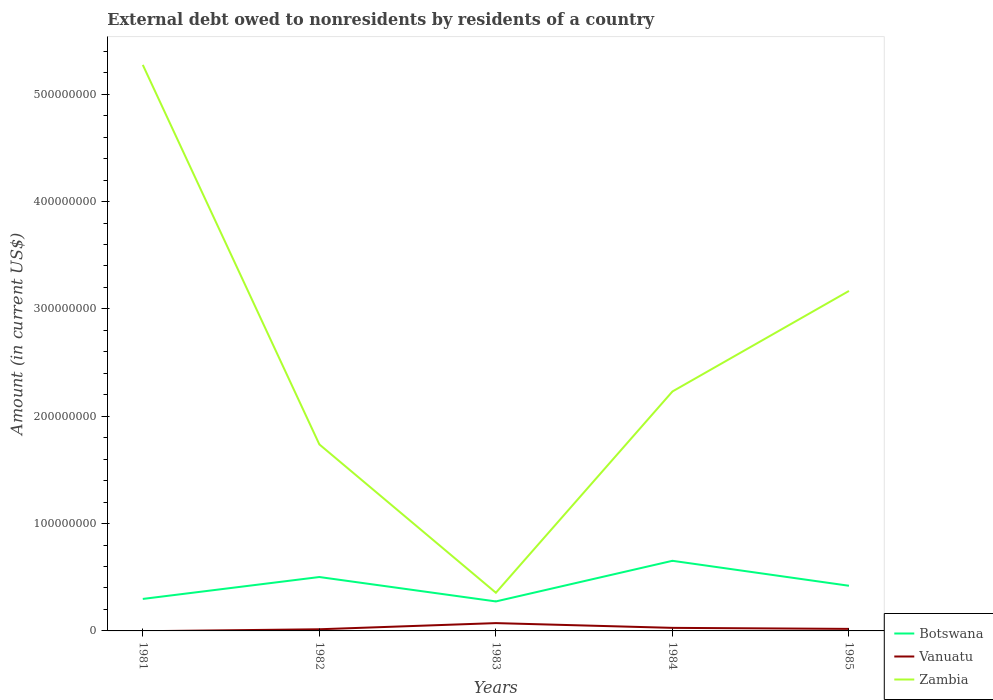Across all years, what is the maximum external debt owed by residents in Botswana?
Offer a very short reply. 2.75e+07. What is the total external debt owed by residents in Zambia in the graph?
Offer a very short reply. -2.81e+08. What is the difference between the highest and the second highest external debt owed by residents in Zambia?
Ensure brevity in your answer.  4.92e+08. What is the difference between the highest and the lowest external debt owed by residents in Zambia?
Ensure brevity in your answer.  2. How many lines are there?
Your answer should be very brief. 3. Are the values on the major ticks of Y-axis written in scientific E-notation?
Make the answer very short. No. Does the graph contain grids?
Provide a short and direct response. No. Where does the legend appear in the graph?
Offer a very short reply. Bottom right. How many legend labels are there?
Keep it short and to the point. 3. What is the title of the graph?
Provide a short and direct response. External debt owed to nonresidents by residents of a country. What is the label or title of the Y-axis?
Ensure brevity in your answer.  Amount (in current US$). What is the Amount (in current US$) in Botswana in 1981?
Your response must be concise. 2.98e+07. What is the Amount (in current US$) of Vanuatu in 1981?
Make the answer very short. 0. What is the Amount (in current US$) of Zambia in 1981?
Your answer should be compact. 5.27e+08. What is the Amount (in current US$) of Botswana in 1982?
Keep it short and to the point. 5.02e+07. What is the Amount (in current US$) in Vanuatu in 1982?
Your answer should be very brief. 1.55e+06. What is the Amount (in current US$) of Zambia in 1982?
Give a very brief answer. 1.74e+08. What is the Amount (in current US$) in Botswana in 1983?
Provide a short and direct response. 2.75e+07. What is the Amount (in current US$) of Vanuatu in 1983?
Your answer should be very brief. 7.28e+06. What is the Amount (in current US$) in Zambia in 1983?
Keep it short and to the point. 3.56e+07. What is the Amount (in current US$) in Botswana in 1984?
Ensure brevity in your answer.  6.53e+07. What is the Amount (in current US$) of Vanuatu in 1984?
Provide a short and direct response. 2.85e+06. What is the Amount (in current US$) in Zambia in 1984?
Make the answer very short. 2.23e+08. What is the Amount (in current US$) of Botswana in 1985?
Give a very brief answer. 4.21e+07. What is the Amount (in current US$) of Vanuatu in 1985?
Your response must be concise. 1.89e+06. What is the Amount (in current US$) of Zambia in 1985?
Offer a terse response. 3.17e+08. Across all years, what is the maximum Amount (in current US$) of Botswana?
Offer a very short reply. 6.53e+07. Across all years, what is the maximum Amount (in current US$) of Vanuatu?
Offer a terse response. 7.28e+06. Across all years, what is the maximum Amount (in current US$) of Zambia?
Make the answer very short. 5.27e+08. Across all years, what is the minimum Amount (in current US$) of Botswana?
Provide a short and direct response. 2.75e+07. Across all years, what is the minimum Amount (in current US$) in Vanuatu?
Your answer should be very brief. 0. Across all years, what is the minimum Amount (in current US$) of Zambia?
Your answer should be compact. 3.56e+07. What is the total Amount (in current US$) in Botswana in the graph?
Offer a terse response. 2.15e+08. What is the total Amount (in current US$) of Vanuatu in the graph?
Ensure brevity in your answer.  1.36e+07. What is the total Amount (in current US$) of Zambia in the graph?
Offer a terse response. 1.28e+09. What is the difference between the Amount (in current US$) of Botswana in 1981 and that in 1982?
Your answer should be very brief. -2.04e+07. What is the difference between the Amount (in current US$) in Zambia in 1981 and that in 1982?
Provide a succinct answer. 3.54e+08. What is the difference between the Amount (in current US$) in Botswana in 1981 and that in 1983?
Make the answer very short. 2.33e+06. What is the difference between the Amount (in current US$) in Zambia in 1981 and that in 1983?
Make the answer very short. 4.92e+08. What is the difference between the Amount (in current US$) in Botswana in 1981 and that in 1984?
Provide a succinct answer. -3.55e+07. What is the difference between the Amount (in current US$) of Zambia in 1981 and that in 1984?
Your answer should be compact. 3.04e+08. What is the difference between the Amount (in current US$) of Botswana in 1981 and that in 1985?
Offer a terse response. -1.23e+07. What is the difference between the Amount (in current US$) of Zambia in 1981 and that in 1985?
Make the answer very short. 2.11e+08. What is the difference between the Amount (in current US$) in Botswana in 1982 and that in 1983?
Offer a very short reply. 2.27e+07. What is the difference between the Amount (in current US$) in Vanuatu in 1982 and that in 1983?
Your answer should be compact. -5.74e+06. What is the difference between the Amount (in current US$) in Zambia in 1982 and that in 1983?
Offer a very short reply. 1.38e+08. What is the difference between the Amount (in current US$) of Botswana in 1982 and that in 1984?
Your answer should be compact. -1.51e+07. What is the difference between the Amount (in current US$) of Vanuatu in 1982 and that in 1984?
Offer a very short reply. -1.30e+06. What is the difference between the Amount (in current US$) of Zambia in 1982 and that in 1984?
Your answer should be compact. -4.93e+07. What is the difference between the Amount (in current US$) of Botswana in 1982 and that in 1985?
Give a very brief answer. 8.14e+06. What is the difference between the Amount (in current US$) of Vanuatu in 1982 and that in 1985?
Your response must be concise. -3.44e+05. What is the difference between the Amount (in current US$) in Zambia in 1982 and that in 1985?
Your answer should be compact. -1.43e+08. What is the difference between the Amount (in current US$) of Botswana in 1983 and that in 1984?
Your answer should be compact. -3.79e+07. What is the difference between the Amount (in current US$) of Vanuatu in 1983 and that in 1984?
Ensure brevity in your answer.  4.44e+06. What is the difference between the Amount (in current US$) of Zambia in 1983 and that in 1984?
Give a very brief answer. -1.88e+08. What is the difference between the Amount (in current US$) in Botswana in 1983 and that in 1985?
Make the answer very short. -1.46e+07. What is the difference between the Amount (in current US$) of Vanuatu in 1983 and that in 1985?
Offer a terse response. 5.39e+06. What is the difference between the Amount (in current US$) in Zambia in 1983 and that in 1985?
Give a very brief answer. -2.81e+08. What is the difference between the Amount (in current US$) in Botswana in 1984 and that in 1985?
Provide a succinct answer. 2.33e+07. What is the difference between the Amount (in current US$) of Vanuatu in 1984 and that in 1985?
Offer a very short reply. 9.53e+05. What is the difference between the Amount (in current US$) of Zambia in 1984 and that in 1985?
Ensure brevity in your answer.  -9.37e+07. What is the difference between the Amount (in current US$) in Botswana in 1981 and the Amount (in current US$) in Vanuatu in 1982?
Your response must be concise. 2.82e+07. What is the difference between the Amount (in current US$) in Botswana in 1981 and the Amount (in current US$) in Zambia in 1982?
Ensure brevity in your answer.  -1.44e+08. What is the difference between the Amount (in current US$) of Botswana in 1981 and the Amount (in current US$) of Vanuatu in 1983?
Offer a terse response. 2.25e+07. What is the difference between the Amount (in current US$) in Botswana in 1981 and the Amount (in current US$) in Zambia in 1983?
Give a very brief answer. -5.77e+06. What is the difference between the Amount (in current US$) of Botswana in 1981 and the Amount (in current US$) of Vanuatu in 1984?
Provide a short and direct response. 2.70e+07. What is the difference between the Amount (in current US$) of Botswana in 1981 and the Amount (in current US$) of Zambia in 1984?
Your response must be concise. -1.93e+08. What is the difference between the Amount (in current US$) in Botswana in 1981 and the Amount (in current US$) in Vanuatu in 1985?
Keep it short and to the point. 2.79e+07. What is the difference between the Amount (in current US$) in Botswana in 1981 and the Amount (in current US$) in Zambia in 1985?
Your answer should be compact. -2.87e+08. What is the difference between the Amount (in current US$) in Botswana in 1982 and the Amount (in current US$) in Vanuatu in 1983?
Ensure brevity in your answer.  4.29e+07. What is the difference between the Amount (in current US$) in Botswana in 1982 and the Amount (in current US$) in Zambia in 1983?
Provide a short and direct response. 1.46e+07. What is the difference between the Amount (in current US$) in Vanuatu in 1982 and the Amount (in current US$) in Zambia in 1983?
Provide a short and direct response. -3.40e+07. What is the difference between the Amount (in current US$) in Botswana in 1982 and the Amount (in current US$) in Vanuatu in 1984?
Make the answer very short. 4.74e+07. What is the difference between the Amount (in current US$) of Botswana in 1982 and the Amount (in current US$) of Zambia in 1984?
Ensure brevity in your answer.  -1.73e+08. What is the difference between the Amount (in current US$) in Vanuatu in 1982 and the Amount (in current US$) in Zambia in 1984?
Offer a very short reply. -2.22e+08. What is the difference between the Amount (in current US$) in Botswana in 1982 and the Amount (in current US$) in Vanuatu in 1985?
Keep it short and to the point. 4.83e+07. What is the difference between the Amount (in current US$) in Botswana in 1982 and the Amount (in current US$) in Zambia in 1985?
Offer a terse response. -2.67e+08. What is the difference between the Amount (in current US$) of Vanuatu in 1982 and the Amount (in current US$) of Zambia in 1985?
Your answer should be compact. -3.15e+08. What is the difference between the Amount (in current US$) in Botswana in 1983 and the Amount (in current US$) in Vanuatu in 1984?
Your answer should be very brief. 2.46e+07. What is the difference between the Amount (in current US$) in Botswana in 1983 and the Amount (in current US$) in Zambia in 1984?
Your answer should be compact. -1.96e+08. What is the difference between the Amount (in current US$) in Vanuatu in 1983 and the Amount (in current US$) in Zambia in 1984?
Make the answer very short. -2.16e+08. What is the difference between the Amount (in current US$) of Botswana in 1983 and the Amount (in current US$) of Vanuatu in 1985?
Your answer should be very brief. 2.56e+07. What is the difference between the Amount (in current US$) in Botswana in 1983 and the Amount (in current US$) in Zambia in 1985?
Your answer should be compact. -2.89e+08. What is the difference between the Amount (in current US$) of Vanuatu in 1983 and the Amount (in current US$) of Zambia in 1985?
Ensure brevity in your answer.  -3.09e+08. What is the difference between the Amount (in current US$) of Botswana in 1984 and the Amount (in current US$) of Vanuatu in 1985?
Your response must be concise. 6.34e+07. What is the difference between the Amount (in current US$) of Botswana in 1984 and the Amount (in current US$) of Zambia in 1985?
Your answer should be very brief. -2.51e+08. What is the difference between the Amount (in current US$) of Vanuatu in 1984 and the Amount (in current US$) of Zambia in 1985?
Provide a short and direct response. -3.14e+08. What is the average Amount (in current US$) in Botswana per year?
Your answer should be compact. 4.30e+07. What is the average Amount (in current US$) in Vanuatu per year?
Your response must be concise. 2.71e+06. What is the average Amount (in current US$) of Zambia per year?
Your answer should be very brief. 2.55e+08. In the year 1981, what is the difference between the Amount (in current US$) of Botswana and Amount (in current US$) of Zambia?
Give a very brief answer. -4.98e+08. In the year 1982, what is the difference between the Amount (in current US$) of Botswana and Amount (in current US$) of Vanuatu?
Provide a short and direct response. 4.87e+07. In the year 1982, what is the difference between the Amount (in current US$) of Botswana and Amount (in current US$) of Zambia?
Give a very brief answer. -1.24e+08. In the year 1982, what is the difference between the Amount (in current US$) of Vanuatu and Amount (in current US$) of Zambia?
Offer a terse response. -1.72e+08. In the year 1983, what is the difference between the Amount (in current US$) in Botswana and Amount (in current US$) in Vanuatu?
Your answer should be very brief. 2.02e+07. In the year 1983, what is the difference between the Amount (in current US$) of Botswana and Amount (in current US$) of Zambia?
Provide a succinct answer. -8.10e+06. In the year 1983, what is the difference between the Amount (in current US$) of Vanuatu and Amount (in current US$) of Zambia?
Make the answer very short. -2.83e+07. In the year 1984, what is the difference between the Amount (in current US$) of Botswana and Amount (in current US$) of Vanuatu?
Your answer should be very brief. 6.25e+07. In the year 1984, what is the difference between the Amount (in current US$) in Botswana and Amount (in current US$) in Zambia?
Provide a succinct answer. -1.58e+08. In the year 1984, what is the difference between the Amount (in current US$) in Vanuatu and Amount (in current US$) in Zambia?
Offer a terse response. -2.20e+08. In the year 1985, what is the difference between the Amount (in current US$) in Botswana and Amount (in current US$) in Vanuatu?
Your response must be concise. 4.02e+07. In the year 1985, what is the difference between the Amount (in current US$) in Botswana and Amount (in current US$) in Zambia?
Make the answer very short. -2.75e+08. In the year 1985, what is the difference between the Amount (in current US$) in Vanuatu and Amount (in current US$) in Zambia?
Ensure brevity in your answer.  -3.15e+08. What is the ratio of the Amount (in current US$) in Botswana in 1981 to that in 1982?
Your response must be concise. 0.59. What is the ratio of the Amount (in current US$) in Zambia in 1981 to that in 1982?
Offer a terse response. 3.03. What is the ratio of the Amount (in current US$) in Botswana in 1981 to that in 1983?
Offer a very short reply. 1.08. What is the ratio of the Amount (in current US$) of Zambia in 1981 to that in 1983?
Ensure brevity in your answer.  14.83. What is the ratio of the Amount (in current US$) in Botswana in 1981 to that in 1984?
Ensure brevity in your answer.  0.46. What is the ratio of the Amount (in current US$) in Zambia in 1981 to that in 1984?
Offer a terse response. 2.36. What is the ratio of the Amount (in current US$) in Botswana in 1981 to that in 1985?
Ensure brevity in your answer.  0.71. What is the ratio of the Amount (in current US$) of Zambia in 1981 to that in 1985?
Your response must be concise. 1.66. What is the ratio of the Amount (in current US$) of Botswana in 1982 to that in 1983?
Keep it short and to the point. 1.83. What is the ratio of the Amount (in current US$) of Vanuatu in 1982 to that in 1983?
Your answer should be compact. 0.21. What is the ratio of the Amount (in current US$) of Zambia in 1982 to that in 1983?
Offer a terse response. 4.89. What is the ratio of the Amount (in current US$) of Botswana in 1982 to that in 1984?
Make the answer very short. 0.77. What is the ratio of the Amount (in current US$) in Vanuatu in 1982 to that in 1984?
Make the answer very short. 0.54. What is the ratio of the Amount (in current US$) of Zambia in 1982 to that in 1984?
Your response must be concise. 0.78. What is the ratio of the Amount (in current US$) of Botswana in 1982 to that in 1985?
Keep it short and to the point. 1.19. What is the ratio of the Amount (in current US$) in Vanuatu in 1982 to that in 1985?
Provide a succinct answer. 0.82. What is the ratio of the Amount (in current US$) of Zambia in 1982 to that in 1985?
Your response must be concise. 0.55. What is the ratio of the Amount (in current US$) in Botswana in 1983 to that in 1984?
Provide a succinct answer. 0.42. What is the ratio of the Amount (in current US$) of Vanuatu in 1983 to that in 1984?
Give a very brief answer. 2.56. What is the ratio of the Amount (in current US$) in Zambia in 1983 to that in 1984?
Your answer should be compact. 0.16. What is the ratio of the Amount (in current US$) in Botswana in 1983 to that in 1985?
Your answer should be compact. 0.65. What is the ratio of the Amount (in current US$) of Vanuatu in 1983 to that in 1985?
Keep it short and to the point. 3.85. What is the ratio of the Amount (in current US$) in Zambia in 1983 to that in 1985?
Offer a terse response. 0.11. What is the ratio of the Amount (in current US$) in Botswana in 1984 to that in 1985?
Provide a succinct answer. 1.55. What is the ratio of the Amount (in current US$) of Vanuatu in 1984 to that in 1985?
Your response must be concise. 1.5. What is the ratio of the Amount (in current US$) of Zambia in 1984 to that in 1985?
Make the answer very short. 0.7. What is the difference between the highest and the second highest Amount (in current US$) of Botswana?
Give a very brief answer. 1.51e+07. What is the difference between the highest and the second highest Amount (in current US$) of Vanuatu?
Offer a very short reply. 4.44e+06. What is the difference between the highest and the second highest Amount (in current US$) of Zambia?
Your response must be concise. 2.11e+08. What is the difference between the highest and the lowest Amount (in current US$) in Botswana?
Give a very brief answer. 3.79e+07. What is the difference between the highest and the lowest Amount (in current US$) in Vanuatu?
Give a very brief answer. 7.28e+06. What is the difference between the highest and the lowest Amount (in current US$) in Zambia?
Your answer should be very brief. 4.92e+08. 